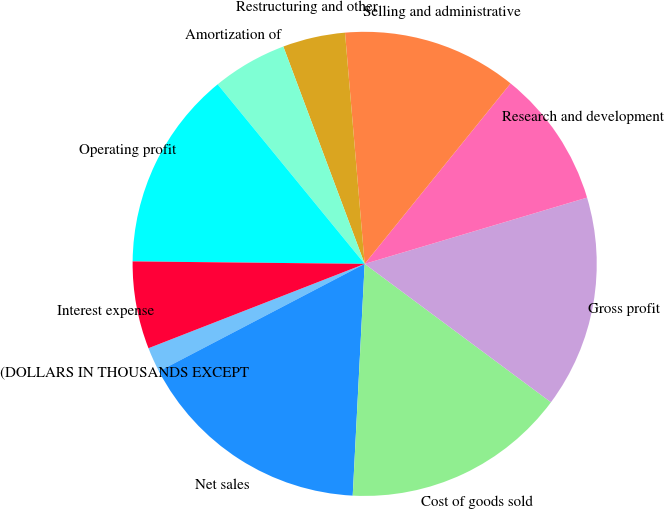Convert chart. <chart><loc_0><loc_0><loc_500><loc_500><pie_chart><fcel>(DOLLARS IN THOUSANDS EXCEPT<fcel>Net sales<fcel>Cost of goods sold<fcel>Gross profit<fcel>Research and development<fcel>Selling and administrative<fcel>Restructuring and other<fcel>Amortization of<fcel>Operating profit<fcel>Interest expense<nl><fcel>1.74%<fcel>16.52%<fcel>15.65%<fcel>14.78%<fcel>9.57%<fcel>12.17%<fcel>4.35%<fcel>5.22%<fcel>13.91%<fcel>6.09%<nl></chart> 